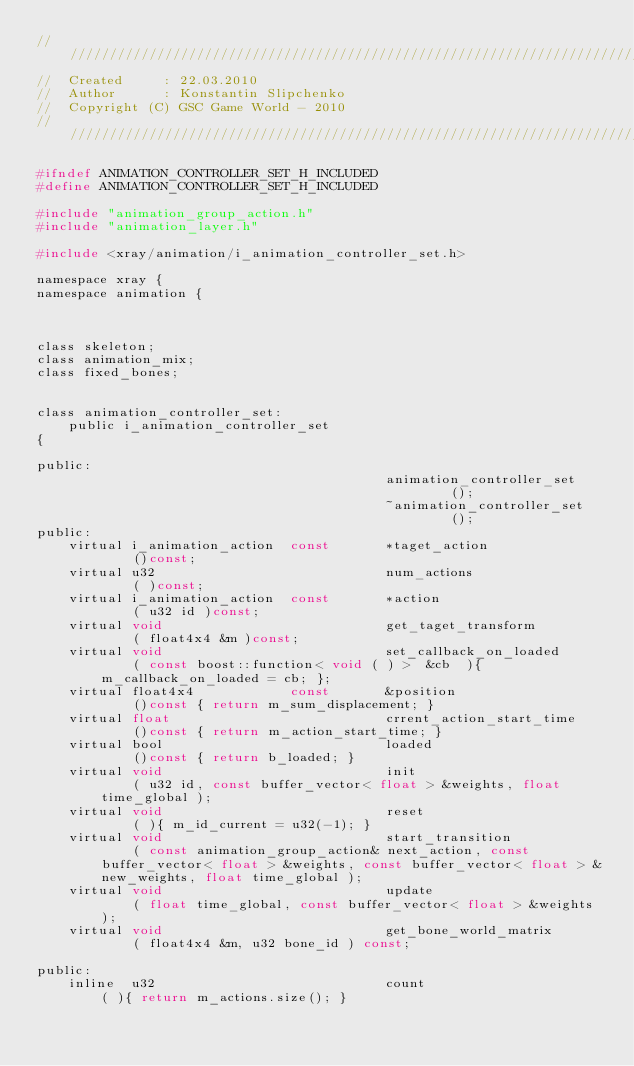Convert code to text. <code><loc_0><loc_0><loc_500><loc_500><_C_>////////////////////////////////////////////////////////////////////////////
//	Created		: 22.03.2010
//	Author		: Konstantin Slipchenko
//	Copyright (C) GSC Game World - 2010
////////////////////////////////////////////////////////////////////////////

#ifndef ANIMATION_CONTROLLER_SET_H_INCLUDED
#define ANIMATION_CONTROLLER_SET_H_INCLUDED

#include "animation_group_action.h"
#include "animation_layer.h"

#include <xray/animation/i_animation_controller_set.h>

namespace xray {
namespace animation {



class skeleton;
class animation_mix;
class fixed_bones;


class animation_controller_set:
	public i_animation_controller_set
{

public:
											animation_controller_set		();
											~animation_controller_set		();
public:
	virtual i_animation_action	const		*taget_action					()const;
	virtual u32								num_actions						( )const;
	virtual i_animation_action	const		*action							( u32 id )const;
	virtual	void							get_taget_transform				( float4x4 &m )const;
	virtual void							set_callback_on_loaded			( const boost::function< void ( ) >	 &cb  ){ m_callback_on_loaded = cb; };
	virtual	float4x4			const		&position						()const	{ return m_sum_displacement; }
	virtual float							crrent_action_start_time		()const { return m_action_start_time; }
	virtual	bool							loaded							()const { return b_loaded; }
	virtual	void							init							( u32 id, const buffer_vector< float > &weights, float time_global );
	virtual	void							reset							( ){ m_id_current = u32(-1); }
	virtual	void							start_transition				( const animation_group_action& next_action, const buffer_vector< float > &weights, const buffer_vector< float > &new_weights, float time_global );
	virtual	void							update							( float time_global, const buffer_vector< float > &weights );
	virtual	void							get_bone_world_matrix			( float4x4 &m, u32 bone_id ) const;

public:
	inline	u32								count						( ){ return m_actions.size(); }</code> 